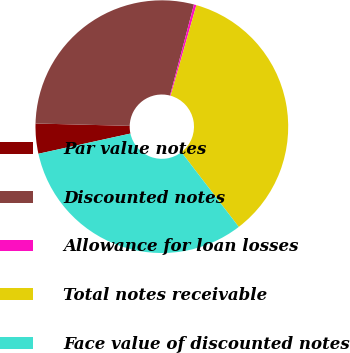<chart> <loc_0><loc_0><loc_500><loc_500><pie_chart><fcel>Par value notes<fcel>Discounted notes<fcel>Allowance for loan losses<fcel>Total notes receivable<fcel>Face value of discounted notes<nl><fcel>3.84%<fcel>28.69%<fcel>0.32%<fcel>35.17%<fcel>31.98%<nl></chart> 